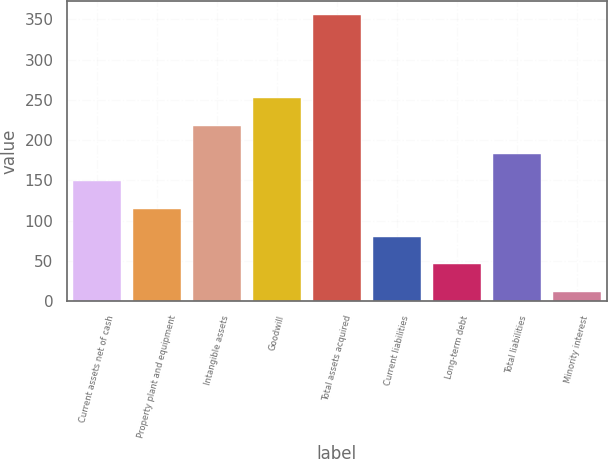Convert chart to OTSL. <chart><loc_0><loc_0><loc_500><loc_500><bar_chart><fcel>Current assets net of cash<fcel>Property plant and equipment<fcel>Intangible assets<fcel>Goodwill<fcel>Total assets acquired<fcel>Current liabilities<fcel>Long-term debt<fcel>Total liabilities<fcel>Minority interest<nl><fcel>148.6<fcel>114.2<fcel>217.4<fcel>251.8<fcel>355<fcel>79.8<fcel>45.4<fcel>183<fcel>11<nl></chart> 